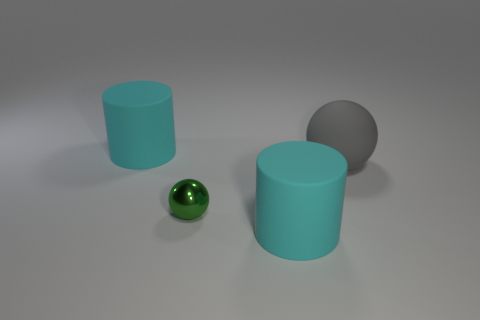Do the object that is behind the gray ball and the small green metallic ball have the same size?
Your response must be concise. No. There is a matte ball; how many large rubber objects are in front of it?
Your answer should be very brief. 1. Is the number of small metal objects behind the metal thing less than the number of big matte balls left of the gray ball?
Your response must be concise. No. How many big yellow rubber spheres are there?
Give a very brief answer. 0. The large rubber object in front of the big rubber sphere is what color?
Your answer should be compact. Cyan. The green shiny thing is what size?
Keep it short and to the point. Small. Does the tiny object have the same color as the big cylinder that is behind the small green metallic ball?
Your answer should be compact. No. The matte cylinder in front of the tiny green ball to the left of the big matte ball is what color?
Give a very brief answer. Cyan. Are there any other things that are the same size as the gray object?
Ensure brevity in your answer.  Yes. There is a cyan rubber object in front of the shiny thing; does it have the same shape as the large gray matte object?
Offer a very short reply. No. 